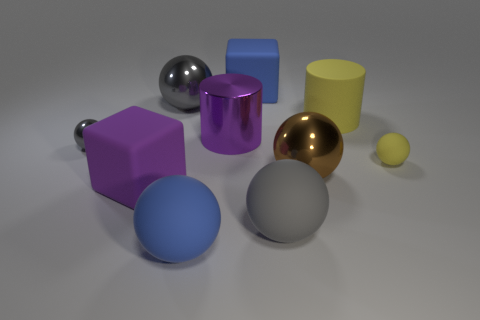How many gray spheres must be subtracted to get 1 gray spheres? 2 Subtract all red blocks. How many gray spheres are left? 3 Subtract all yellow spheres. How many spheres are left? 5 Subtract all brown balls. How many balls are left? 5 Subtract all yellow balls. Subtract all purple blocks. How many balls are left? 5 Subtract all blocks. How many objects are left? 8 Subtract 0 green balls. How many objects are left? 10 Subtract all purple metallic objects. Subtract all brown balls. How many objects are left? 8 Add 8 purple things. How many purple things are left? 10 Add 9 large yellow balls. How many large yellow balls exist? 9 